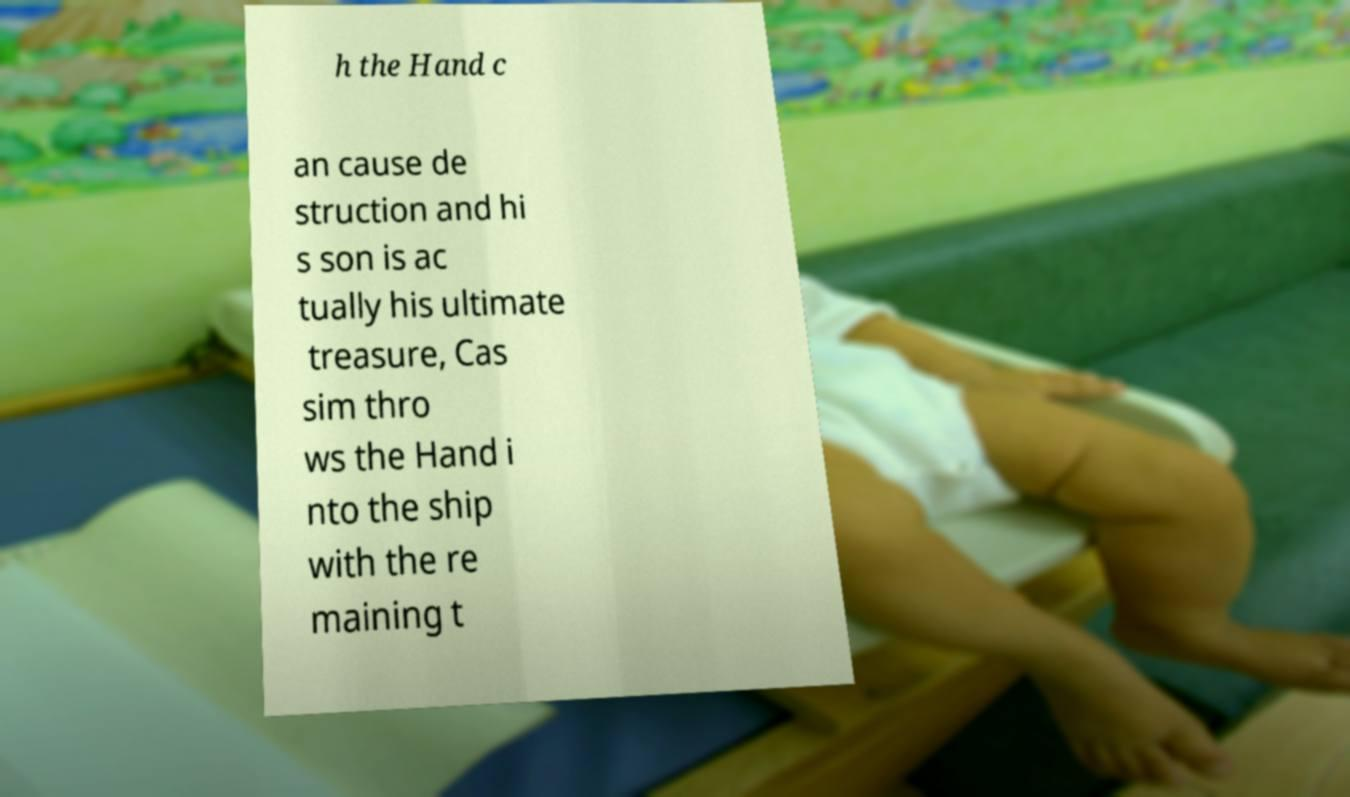There's text embedded in this image that I need extracted. Can you transcribe it verbatim? h the Hand c an cause de struction and hi s son is ac tually his ultimate treasure, Cas sim thro ws the Hand i nto the ship with the re maining t 